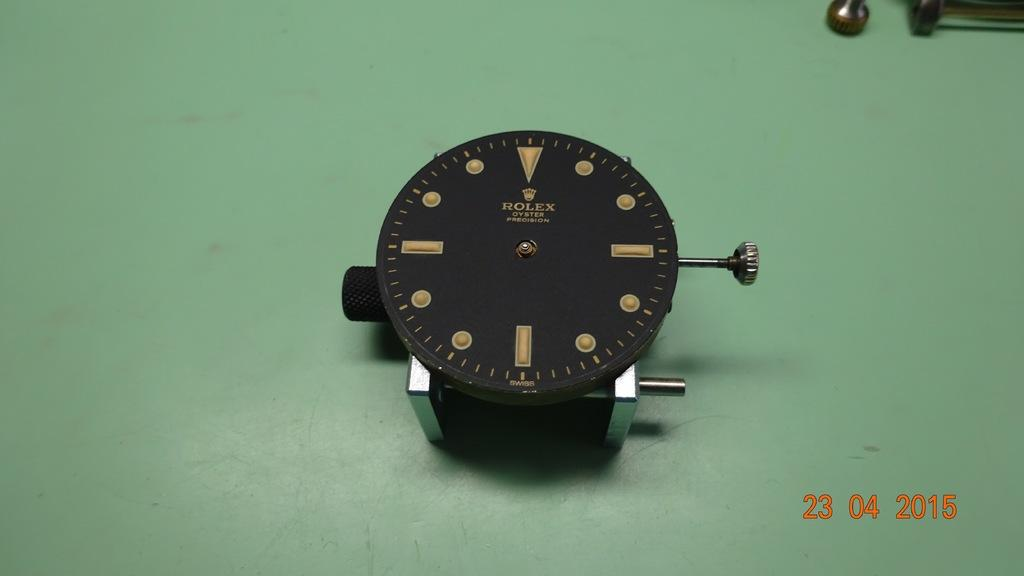<image>
Write a terse but informative summary of the picture. A black and gold Rolex oyster watch without the band. 